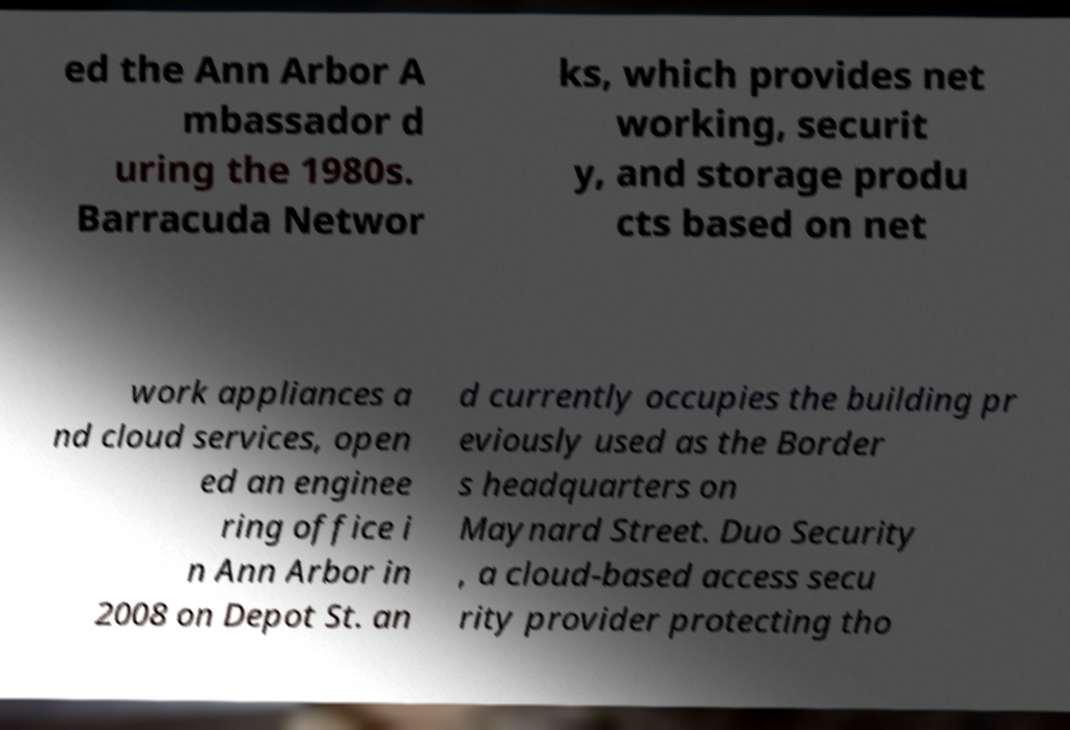Please read and relay the text visible in this image. What does it say? ed the Ann Arbor A mbassador d uring the 1980s. Barracuda Networ ks, which provides net working, securit y, and storage produ cts based on net work appliances a nd cloud services, open ed an enginee ring office i n Ann Arbor in 2008 on Depot St. an d currently occupies the building pr eviously used as the Border s headquarters on Maynard Street. Duo Security , a cloud-based access secu rity provider protecting tho 